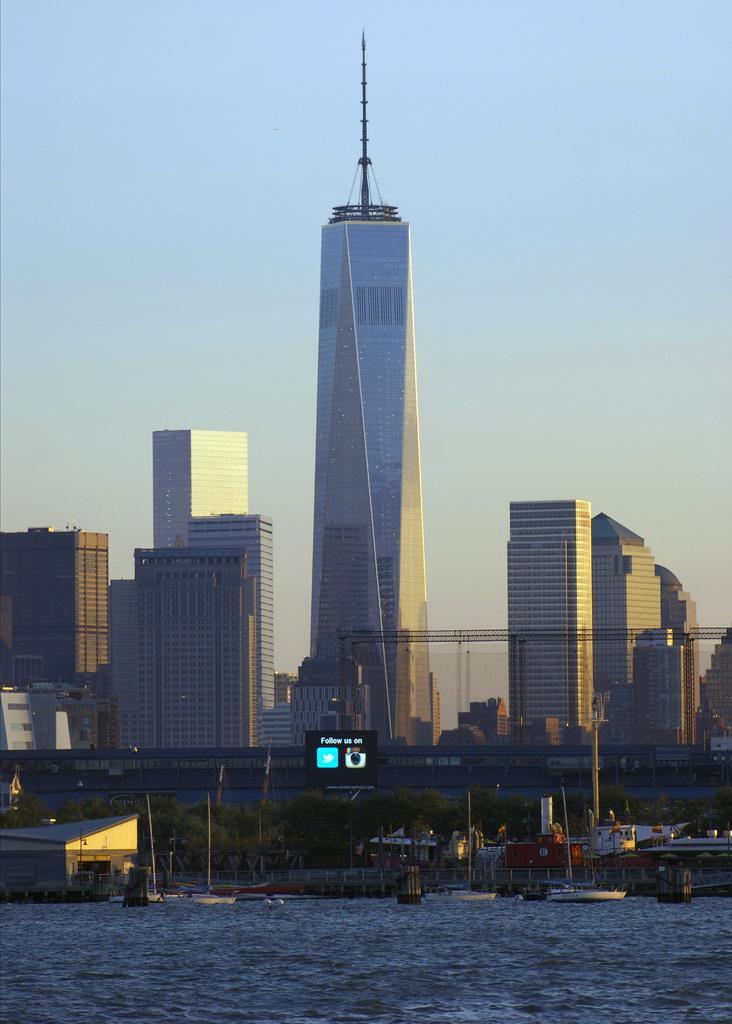What type of vehicles can be seen on the water in the image? There are boats on the water in the image. What type of natural vegetation is visible in the image? There are trees visible in the image. What type of electronic device is present in the image? There is a screen present in the image. What type of buildings can be seen in the image? Skyscrapers are visible in the image. What part of the natural environment is visible in the image? The sky is visible in the image. How many pigs are visible on the screen in the image? There are no pigs visible on the screen in the image. What type of net is used to catch the boats in the image? There is no net present in the image, and boats are not being caught. 